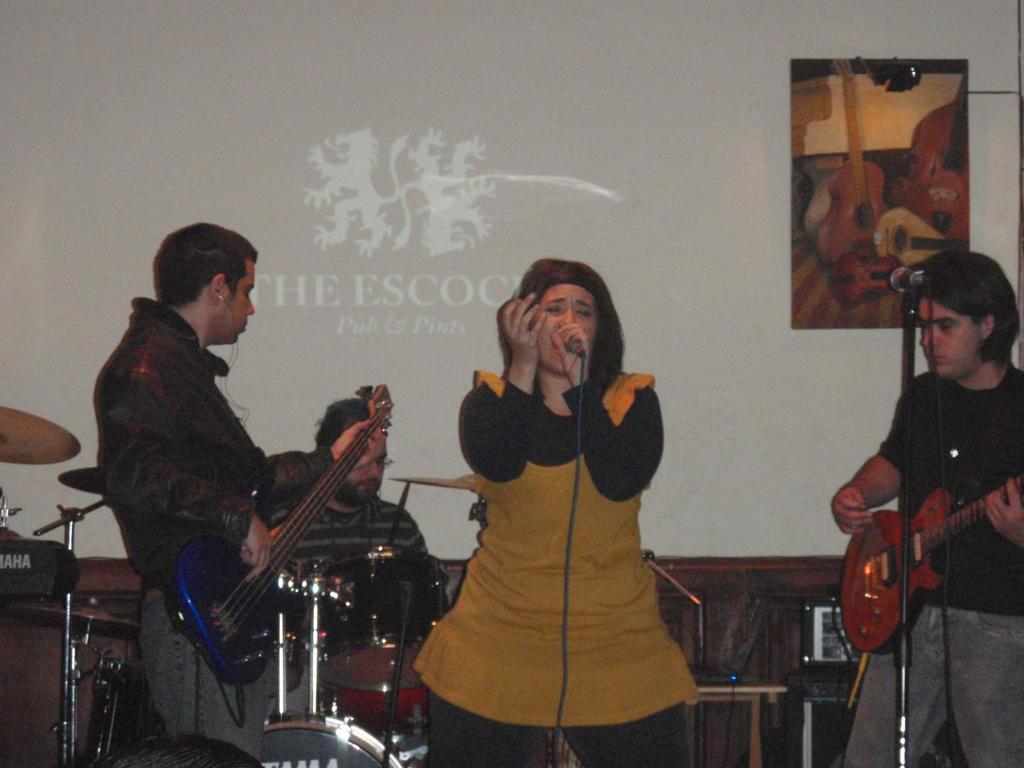How many people are present in the image? There are four people in the image. What is the woman doing in the image? The woman is singing with a microphone. What instrument is the man playing in the image? The man is playing a guitar. How many friends does the dime have in the image? There is no dime present in the image, so it cannot be determined how many friends it might have. 